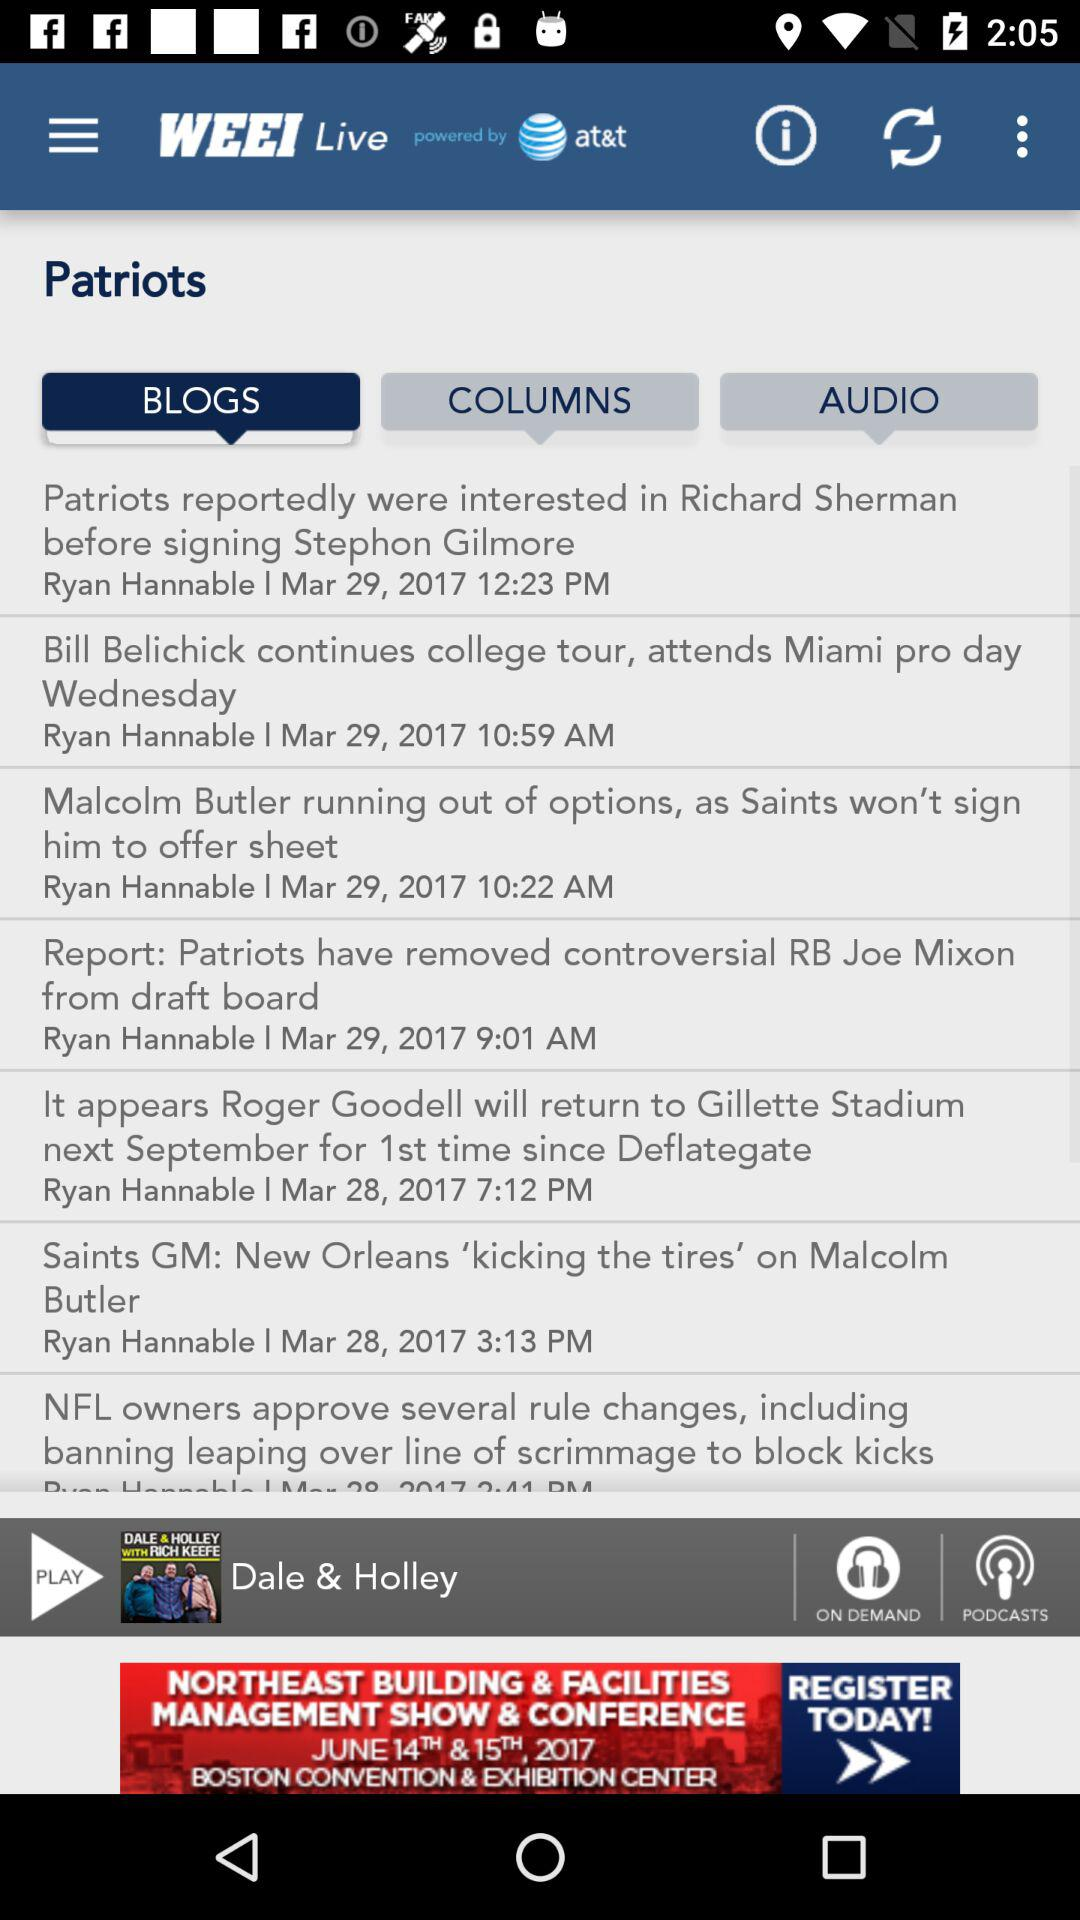Which blog was posted at 12:23 PM? The blog posted at 12:23 PM was "Patriots reportedly were interested in Richard Sherman before signing Stephon Gilmore". 